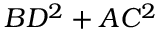Convert formula to latex. <formula><loc_0><loc_0><loc_500><loc_500>B D ^ { 2 } + A C ^ { 2 }</formula> 